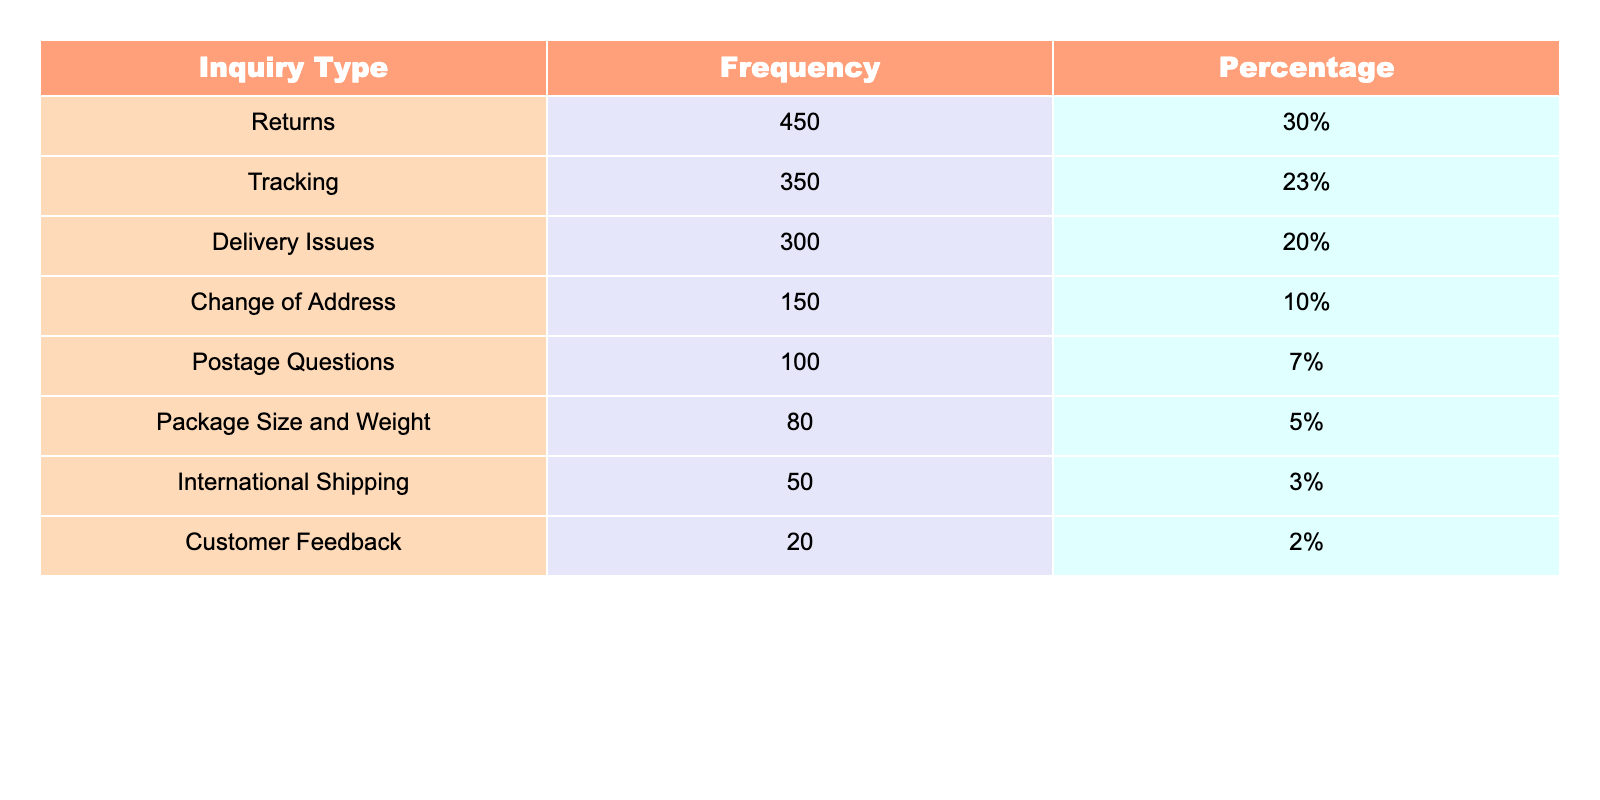What is the frequency of inquiries regarding Returns? The table states that the frequency of inquiries for Returns is 450.
Answer: 450 What percentage of total inquiries are about Tracking? According to the table, the percentage of inquiries about Tracking is 23%.
Answer: 23% Which inquiry type has the highest frequency? By examining the frequencies, Returns has the highest frequency with 450 inquiries.
Answer: Returns What is the difference in frequency between Delivery Issues and Postage Questions? The frequency for Delivery Issues is 300 and for Postage Questions is 100, so the difference is 300 - 100 = 200.
Answer: 200 How many inquiries are related to Change of Address compared to International Shipping? Change of Address has 150 inquiries and International Shipping has 50 inquiries, making the difference 150 - 50 = 100.
Answer: 100 What is the total frequency of all customer inquiries listed? Adding the frequencies from the table: 450 + 350 + 300 + 150 + 100 + 80 + 50 + 20 = 1,500.
Answer: 1500 Is the frequency of Package Size and Weight inquiries more than Customer Feedback inquiries? Yes, Package Size and Weight has a frequency of 80 while Customer Feedback has 20, so 80 > 20 is true.
Answer: Yes What percentage of inquiries are related to issues other than Returns and Tracking? The total frequency of Returns and Tracking is 450 + 350 = 800. The remaining inquiries are 1,500 - 800 = 700, which is 700/1500 * 100 = 46.67%.
Answer: 46.67% Which inquiry type constitutes less than 5% of the total inquiries? Observing the table, International Shipping (3%) and Customer Feedback (2%) both fall below 5%.
Answer: International Shipping and Customer Feedback What is the average frequency of all types of inquiries shown in the table? The total frequency is 1,500 and there are 8 inquiry types, so the average is 1,500/8 = 187.5.
Answer: 187.5 